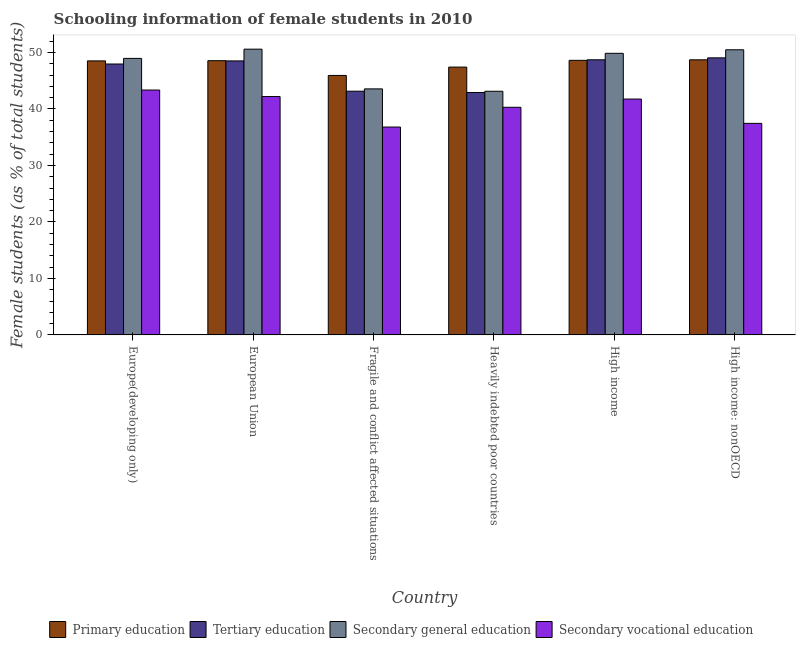How many groups of bars are there?
Your response must be concise. 6. How many bars are there on the 3rd tick from the left?
Give a very brief answer. 4. How many bars are there on the 4th tick from the right?
Make the answer very short. 4. What is the label of the 6th group of bars from the left?
Offer a terse response. High income: nonOECD. In how many cases, is the number of bars for a given country not equal to the number of legend labels?
Provide a short and direct response. 0. What is the percentage of female students in primary education in Europe(developing only)?
Provide a succinct answer. 48.5. Across all countries, what is the maximum percentage of female students in secondary vocational education?
Your response must be concise. 43.34. Across all countries, what is the minimum percentage of female students in secondary education?
Give a very brief answer. 43.13. In which country was the percentage of female students in secondary vocational education maximum?
Give a very brief answer. Europe(developing only). In which country was the percentage of female students in secondary education minimum?
Provide a succinct answer. Heavily indebted poor countries. What is the total percentage of female students in secondary vocational education in the graph?
Ensure brevity in your answer.  241.81. What is the difference between the percentage of female students in secondary education in Fragile and conflict affected situations and that in High income?
Provide a succinct answer. -6.29. What is the difference between the percentage of female students in secondary education in European Union and the percentage of female students in tertiary education in Fragile and conflict affected situations?
Provide a short and direct response. 7.44. What is the average percentage of female students in primary education per country?
Ensure brevity in your answer.  47.95. What is the difference between the percentage of female students in tertiary education and percentage of female students in secondary vocational education in Fragile and conflict affected situations?
Provide a succinct answer. 6.35. What is the ratio of the percentage of female students in secondary vocational education in Fragile and conflict affected situations to that in Heavily indebted poor countries?
Offer a terse response. 0.91. Is the difference between the percentage of female students in secondary vocational education in Fragile and conflict affected situations and Heavily indebted poor countries greater than the difference between the percentage of female students in tertiary education in Fragile and conflict affected situations and Heavily indebted poor countries?
Provide a succinct answer. No. What is the difference between the highest and the second highest percentage of female students in tertiary education?
Offer a terse response. 0.34. What is the difference between the highest and the lowest percentage of female students in tertiary education?
Give a very brief answer. 6.13. In how many countries, is the percentage of female students in tertiary education greater than the average percentage of female students in tertiary education taken over all countries?
Ensure brevity in your answer.  4. Is the sum of the percentage of female students in primary education in Europe(developing only) and Heavily indebted poor countries greater than the maximum percentage of female students in tertiary education across all countries?
Ensure brevity in your answer.  Yes. What does the 2nd bar from the left in High income represents?
Your answer should be compact. Tertiary education. What does the 3rd bar from the right in Europe(developing only) represents?
Offer a terse response. Tertiary education. What is the difference between two consecutive major ticks on the Y-axis?
Give a very brief answer. 10. Does the graph contain grids?
Offer a terse response. No. Where does the legend appear in the graph?
Offer a very short reply. Bottom center. What is the title of the graph?
Ensure brevity in your answer.  Schooling information of female students in 2010. Does "Secondary general" appear as one of the legend labels in the graph?
Your response must be concise. No. What is the label or title of the X-axis?
Your answer should be compact. Country. What is the label or title of the Y-axis?
Provide a short and direct response. Female students (as % of total students). What is the Female students (as % of total students) in Primary education in Europe(developing only)?
Offer a terse response. 48.5. What is the Female students (as % of total students) in Tertiary education in Europe(developing only)?
Provide a short and direct response. 47.95. What is the Female students (as % of total students) in Secondary general education in Europe(developing only)?
Provide a succinct answer. 48.94. What is the Female students (as % of total students) of Secondary vocational education in Europe(developing only)?
Provide a short and direct response. 43.34. What is the Female students (as % of total students) of Primary education in European Union?
Your answer should be very brief. 48.54. What is the Female students (as % of total students) in Tertiary education in European Union?
Provide a succinct answer. 48.5. What is the Female students (as % of total students) in Secondary general education in European Union?
Make the answer very short. 50.58. What is the Female students (as % of total students) of Secondary vocational education in European Union?
Ensure brevity in your answer.  42.19. What is the Female students (as % of total students) of Primary education in Fragile and conflict affected situations?
Provide a short and direct response. 45.93. What is the Female students (as % of total students) in Tertiary education in Fragile and conflict affected situations?
Keep it short and to the point. 43.14. What is the Female students (as % of total students) in Secondary general education in Fragile and conflict affected situations?
Your response must be concise. 43.55. What is the Female students (as % of total students) in Secondary vocational education in Fragile and conflict affected situations?
Your response must be concise. 36.79. What is the Female students (as % of total students) in Primary education in Heavily indebted poor countries?
Your response must be concise. 47.41. What is the Female students (as % of total students) of Tertiary education in Heavily indebted poor countries?
Your answer should be very brief. 42.91. What is the Female students (as % of total students) in Secondary general education in Heavily indebted poor countries?
Your response must be concise. 43.13. What is the Female students (as % of total students) of Secondary vocational education in Heavily indebted poor countries?
Your answer should be compact. 40.29. What is the Female students (as % of total students) in Primary education in High income?
Your answer should be compact. 48.6. What is the Female students (as % of total students) of Tertiary education in High income?
Offer a terse response. 48.7. What is the Female students (as % of total students) in Secondary general education in High income?
Offer a terse response. 49.84. What is the Female students (as % of total students) of Secondary vocational education in High income?
Provide a succinct answer. 41.75. What is the Female students (as % of total students) of Primary education in High income: nonOECD?
Give a very brief answer. 48.69. What is the Female students (as % of total students) in Tertiary education in High income: nonOECD?
Give a very brief answer. 49.04. What is the Female students (as % of total students) of Secondary general education in High income: nonOECD?
Your answer should be very brief. 50.47. What is the Female students (as % of total students) of Secondary vocational education in High income: nonOECD?
Offer a very short reply. 37.45. Across all countries, what is the maximum Female students (as % of total students) of Primary education?
Your response must be concise. 48.69. Across all countries, what is the maximum Female students (as % of total students) of Tertiary education?
Make the answer very short. 49.04. Across all countries, what is the maximum Female students (as % of total students) in Secondary general education?
Your answer should be compact. 50.58. Across all countries, what is the maximum Female students (as % of total students) in Secondary vocational education?
Your answer should be compact. 43.34. Across all countries, what is the minimum Female students (as % of total students) of Primary education?
Ensure brevity in your answer.  45.93. Across all countries, what is the minimum Female students (as % of total students) in Tertiary education?
Offer a terse response. 42.91. Across all countries, what is the minimum Female students (as % of total students) in Secondary general education?
Keep it short and to the point. 43.13. Across all countries, what is the minimum Female students (as % of total students) of Secondary vocational education?
Offer a terse response. 36.79. What is the total Female students (as % of total students) in Primary education in the graph?
Provide a succinct answer. 287.67. What is the total Female students (as % of total students) in Tertiary education in the graph?
Your answer should be compact. 280.24. What is the total Female students (as % of total students) of Secondary general education in the graph?
Your response must be concise. 286.51. What is the total Female students (as % of total students) in Secondary vocational education in the graph?
Give a very brief answer. 241.81. What is the difference between the Female students (as % of total students) of Primary education in Europe(developing only) and that in European Union?
Your answer should be compact. -0.04. What is the difference between the Female students (as % of total students) in Tertiary education in Europe(developing only) and that in European Union?
Offer a very short reply. -0.55. What is the difference between the Female students (as % of total students) of Secondary general education in Europe(developing only) and that in European Union?
Provide a short and direct response. -1.64. What is the difference between the Female students (as % of total students) of Secondary vocational education in Europe(developing only) and that in European Union?
Make the answer very short. 1.15. What is the difference between the Female students (as % of total students) in Primary education in Europe(developing only) and that in Fragile and conflict affected situations?
Provide a short and direct response. 2.57. What is the difference between the Female students (as % of total students) of Tertiary education in Europe(developing only) and that in Fragile and conflict affected situations?
Provide a succinct answer. 4.81. What is the difference between the Female students (as % of total students) of Secondary general education in Europe(developing only) and that in Fragile and conflict affected situations?
Provide a succinct answer. 5.39. What is the difference between the Female students (as % of total students) of Secondary vocational education in Europe(developing only) and that in Fragile and conflict affected situations?
Make the answer very short. 6.55. What is the difference between the Female students (as % of total students) in Primary education in Europe(developing only) and that in Heavily indebted poor countries?
Provide a succinct answer. 1.1. What is the difference between the Female students (as % of total students) in Tertiary education in Europe(developing only) and that in Heavily indebted poor countries?
Your response must be concise. 5.04. What is the difference between the Female students (as % of total students) in Secondary general education in Europe(developing only) and that in Heavily indebted poor countries?
Offer a very short reply. 5.81. What is the difference between the Female students (as % of total students) of Secondary vocational education in Europe(developing only) and that in Heavily indebted poor countries?
Offer a terse response. 3.05. What is the difference between the Female students (as % of total students) of Primary education in Europe(developing only) and that in High income?
Keep it short and to the point. -0.1. What is the difference between the Female students (as % of total students) in Tertiary education in Europe(developing only) and that in High income?
Make the answer very short. -0.75. What is the difference between the Female students (as % of total students) of Secondary general education in Europe(developing only) and that in High income?
Your answer should be compact. -0.9. What is the difference between the Female students (as % of total students) of Secondary vocational education in Europe(developing only) and that in High income?
Provide a succinct answer. 1.6. What is the difference between the Female students (as % of total students) in Primary education in Europe(developing only) and that in High income: nonOECD?
Give a very brief answer. -0.19. What is the difference between the Female students (as % of total students) of Tertiary education in Europe(developing only) and that in High income: nonOECD?
Provide a succinct answer. -1.09. What is the difference between the Female students (as % of total students) in Secondary general education in Europe(developing only) and that in High income: nonOECD?
Provide a short and direct response. -1.53. What is the difference between the Female students (as % of total students) in Secondary vocational education in Europe(developing only) and that in High income: nonOECD?
Your answer should be compact. 5.9. What is the difference between the Female students (as % of total students) in Primary education in European Union and that in Fragile and conflict affected situations?
Provide a short and direct response. 2.61. What is the difference between the Female students (as % of total students) of Tertiary education in European Union and that in Fragile and conflict affected situations?
Offer a terse response. 5.36. What is the difference between the Female students (as % of total students) in Secondary general education in European Union and that in Fragile and conflict affected situations?
Offer a very short reply. 7.03. What is the difference between the Female students (as % of total students) of Secondary vocational education in European Union and that in Fragile and conflict affected situations?
Provide a short and direct response. 5.4. What is the difference between the Female students (as % of total students) of Primary education in European Union and that in Heavily indebted poor countries?
Ensure brevity in your answer.  1.13. What is the difference between the Female students (as % of total students) in Tertiary education in European Union and that in Heavily indebted poor countries?
Your response must be concise. 5.59. What is the difference between the Female students (as % of total students) of Secondary general education in European Union and that in Heavily indebted poor countries?
Keep it short and to the point. 7.45. What is the difference between the Female students (as % of total students) of Secondary vocational education in European Union and that in Heavily indebted poor countries?
Your response must be concise. 1.9. What is the difference between the Female students (as % of total students) of Primary education in European Union and that in High income?
Make the answer very short. -0.06. What is the difference between the Female students (as % of total students) in Tertiary education in European Union and that in High income?
Keep it short and to the point. -0.2. What is the difference between the Female students (as % of total students) in Secondary general education in European Union and that in High income?
Your answer should be compact. 0.74. What is the difference between the Female students (as % of total students) in Secondary vocational education in European Union and that in High income?
Your answer should be very brief. 0.44. What is the difference between the Female students (as % of total students) in Primary education in European Union and that in High income: nonOECD?
Keep it short and to the point. -0.15. What is the difference between the Female students (as % of total students) in Tertiary education in European Union and that in High income: nonOECD?
Make the answer very short. -0.54. What is the difference between the Female students (as % of total students) of Secondary general education in European Union and that in High income: nonOECD?
Make the answer very short. 0.11. What is the difference between the Female students (as % of total students) in Secondary vocational education in European Union and that in High income: nonOECD?
Make the answer very short. 4.74. What is the difference between the Female students (as % of total students) of Primary education in Fragile and conflict affected situations and that in Heavily indebted poor countries?
Give a very brief answer. -1.48. What is the difference between the Female students (as % of total students) of Tertiary education in Fragile and conflict affected situations and that in Heavily indebted poor countries?
Offer a terse response. 0.23. What is the difference between the Female students (as % of total students) in Secondary general education in Fragile and conflict affected situations and that in Heavily indebted poor countries?
Keep it short and to the point. 0.42. What is the difference between the Female students (as % of total students) of Secondary vocational education in Fragile and conflict affected situations and that in Heavily indebted poor countries?
Provide a succinct answer. -3.5. What is the difference between the Female students (as % of total students) of Primary education in Fragile and conflict affected situations and that in High income?
Ensure brevity in your answer.  -2.67. What is the difference between the Female students (as % of total students) of Tertiary education in Fragile and conflict affected situations and that in High income?
Ensure brevity in your answer.  -5.56. What is the difference between the Female students (as % of total students) of Secondary general education in Fragile and conflict affected situations and that in High income?
Make the answer very short. -6.29. What is the difference between the Female students (as % of total students) in Secondary vocational education in Fragile and conflict affected situations and that in High income?
Your answer should be compact. -4.96. What is the difference between the Female students (as % of total students) in Primary education in Fragile and conflict affected situations and that in High income: nonOECD?
Make the answer very short. -2.76. What is the difference between the Female students (as % of total students) in Tertiary education in Fragile and conflict affected situations and that in High income: nonOECD?
Offer a terse response. -5.9. What is the difference between the Female students (as % of total students) of Secondary general education in Fragile and conflict affected situations and that in High income: nonOECD?
Make the answer very short. -6.92. What is the difference between the Female students (as % of total students) of Secondary vocational education in Fragile and conflict affected situations and that in High income: nonOECD?
Make the answer very short. -0.65. What is the difference between the Female students (as % of total students) in Primary education in Heavily indebted poor countries and that in High income?
Your response must be concise. -1.19. What is the difference between the Female students (as % of total students) in Tertiary education in Heavily indebted poor countries and that in High income?
Provide a succinct answer. -5.79. What is the difference between the Female students (as % of total students) in Secondary general education in Heavily indebted poor countries and that in High income?
Ensure brevity in your answer.  -6.71. What is the difference between the Female students (as % of total students) of Secondary vocational education in Heavily indebted poor countries and that in High income?
Make the answer very short. -1.46. What is the difference between the Female students (as % of total students) of Primary education in Heavily indebted poor countries and that in High income: nonOECD?
Make the answer very short. -1.29. What is the difference between the Female students (as % of total students) in Tertiary education in Heavily indebted poor countries and that in High income: nonOECD?
Keep it short and to the point. -6.13. What is the difference between the Female students (as % of total students) of Secondary general education in Heavily indebted poor countries and that in High income: nonOECD?
Give a very brief answer. -7.34. What is the difference between the Female students (as % of total students) in Secondary vocational education in Heavily indebted poor countries and that in High income: nonOECD?
Make the answer very short. 2.84. What is the difference between the Female students (as % of total students) in Primary education in High income and that in High income: nonOECD?
Make the answer very short. -0.09. What is the difference between the Female students (as % of total students) of Tertiary education in High income and that in High income: nonOECD?
Ensure brevity in your answer.  -0.34. What is the difference between the Female students (as % of total students) of Secondary general education in High income and that in High income: nonOECD?
Keep it short and to the point. -0.63. What is the difference between the Female students (as % of total students) of Secondary vocational education in High income and that in High income: nonOECD?
Provide a succinct answer. 4.3. What is the difference between the Female students (as % of total students) in Primary education in Europe(developing only) and the Female students (as % of total students) in Tertiary education in European Union?
Your answer should be compact. 0. What is the difference between the Female students (as % of total students) in Primary education in Europe(developing only) and the Female students (as % of total students) in Secondary general education in European Union?
Provide a succinct answer. -2.08. What is the difference between the Female students (as % of total students) of Primary education in Europe(developing only) and the Female students (as % of total students) of Secondary vocational education in European Union?
Ensure brevity in your answer.  6.31. What is the difference between the Female students (as % of total students) in Tertiary education in Europe(developing only) and the Female students (as % of total students) in Secondary general education in European Union?
Offer a very short reply. -2.63. What is the difference between the Female students (as % of total students) of Tertiary education in Europe(developing only) and the Female students (as % of total students) of Secondary vocational education in European Union?
Offer a very short reply. 5.76. What is the difference between the Female students (as % of total students) in Secondary general education in Europe(developing only) and the Female students (as % of total students) in Secondary vocational education in European Union?
Give a very brief answer. 6.75. What is the difference between the Female students (as % of total students) of Primary education in Europe(developing only) and the Female students (as % of total students) of Tertiary education in Fragile and conflict affected situations?
Ensure brevity in your answer.  5.36. What is the difference between the Female students (as % of total students) in Primary education in Europe(developing only) and the Female students (as % of total students) in Secondary general education in Fragile and conflict affected situations?
Give a very brief answer. 4.95. What is the difference between the Female students (as % of total students) in Primary education in Europe(developing only) and the Female students (as % of total students) in Secondary vocational education in Fragile and conflict affected situations?
Keep it short and to the point. 11.71. What is the difference between the Female students (as % of total students) of Tertiary education in Europe(developing only) and the Female students (as % of total students) of Secondary general education in Fragile and conflict affected situations?
Provide a succinct answer. 4.4. What is the difference between the Female students (as % of total students) in Tertiary education in Europe(developing only) and the Female students (as % of total students) in Secondary vocational education in Fragile and conflict affected situations?
Ensure brevity in your answer.  11.16. What is the difference between the Female students (as % of total students) in Secondary general education in Europe(developing only) and the Female students (as % of total students) in Secondary vocational education in Fragile and conflict affected situations?
Your answer should be compact. 12.15. What is the difference between the Female students (as % of total students) of Primary education in Europe(developing only) and the Female students (as % of total students) of Tertiary education in Heavily indebted poor countries?
Your answer should be compact. 5.59. What is the difference between the Female students (as % of total students) of Primary education in Europe(developing only) and the Female students (as % of total students) of Secondary general education in Heavily indebted poor countries?
Ensure brevity in your answer.  5.38. What is the difference between the Female students (as % of total students) in Primary education in Europe(developing only) and the Female students (as % of total students) in Secondary vocational education in Heavily indebted poor countries?
Provide a short and direct response. 8.21. What is the difference between the Female students (as % of total students) of Tertiary education in Europe(developing only) and the Female students (as % of total students) of Secondary general education in Heavily indebted poor countries?
Make the answer very short. 4.82. What is the difference between the Female students (as % of total students) in Tertiary education in Europe(developing only) and the Female students (as % of total students) in Secondary vocational education in Heavily indebted poor countries?
Offer a terse response. 7.66. What is the difference between the Female students (as % of total students) of Secondary general education in Europe(developing only) and the Female students (as % of total students) of Secondary vocational education in Heavily indebted poor countries?
Keep it short and to the point. 8.65. What is the difference between the Female students (as % of total students) of Primary education in Europe(developing only) and the Female students (as % of total students) of Tertiary education in High income?
Your answer should be very brief. -0.19. What is the difference between the Female students (as % of total students) of Primary education in Europe(developing only) and the Female students (as % of total students) of Secondary general education in High income?
Your answer should be very brief. -1.34. What is the difference between the Female students (as % of total students) in Primary education in Europe(developing only) and the Female students (as % of total students) in Secondary vocational education in High income?
Offer a terse response. 6.76. What is the difference between the Female students (as % of total students) in Tertiary education in Europe(developing only) and the Female students (as % of total students) in Secondary general education in High income?
Offer a very short reply. -1.89. What is the difference between the Female students (as % of total students) in Tertiary education in Europe(developing only) and the Female students (as % of total students) in Secondary vocational education in High income?
Offer a very short reply. 6.2. What is the difference between the Female students (as % of total students) in Secondary general education in Europe(developing only) and the Female students (as % of total students) in Secondary vocational education in High income?
Ensure brevity in your answer.  7.2. What is the difference between the Female students (as % of total students) of Primary education in Europe(developing only) and the Female students (as % of total students) of Tertiary education in High income: nonOECD?
Give a very brief answer. -0.54. What is the difference between the Female students (as % of total students) in Primary education in Europe(developing only) and the Female students (as % of total students) in Secondary general education in High income: nonOECD?
Your response must be concise. -1.97. What is the difference between the Female students (as % of total students) in Primary education in Europe(developing only) and the Female students (as % of total students) in Secondary vocational education in High income: nonOECD?
Your answer should be compact. 11.06. What is the difference between the Female students (as % of total students) in Tertiary education in Europe(developing only) and the Female students (as % of total students) in Secondary general education in High income: nonOECD?
Offer a terse response. -2.52. What is the difference between the Female students (as % of total students) in Tertiary education in Europe(developing only) and the Female students (as % of total students) in Secondary vocational education in High income: nonOECD?
Keep it short and to the point. 10.51. What is the difference between the Female students (as % of total students) of Secondary general education in Europe(developing only) and the Female students (as % of total students) of Secondary vocational education in High income: nonOECD?
Your response must be concise. 11.5. What is the difference between the Female students (as % of total students) of Primary education in European Union and the Female students (as % of total students) of Tertiary education in Fragile and conflict affected situations?
Keep it short and to the point. 5.4. What is the difference between the Female students (as % of total students) of Primary education in European Union and the Female students (as % of total students) of Secondary general education in Fragile and conflict affected situations?
Provide a short and direct response. 4.99. What is the difference between the Female students (as % of total students) in Primary education in European Union and the Female students (as % of total students) in Secondary vocational education in Fragile and conflict affected situations?
Offer a terse response. 11.75. What is the difference between the Female students (as % of total students) in Tertiary education in European Union and the Female students (as % of total students) in Secondary general education in Fragile and conflict affected situations?
Keep it short and to the point. 4.95. What is the difference between the Female students (as % of total students) of Tertiary education in European Union and the Female students (as % of total students) of Secondary vocational education in Fragile and conflict affected situations?
Offer a terse response. 11.71. What is the difference between the Female students (as % of total students) of Secondary general education in European Union and the Female students (as % of total students) of Secondary vocational education in Fragile and conflict affected situations?
Make the answer very short. 13.79. What is the difference between the Female students (as % of total students) of Primary education in European Union and the Female students (as % of total students) of Tertiary education in Heavily indebted poor countries?
Offer a terse response. 5.63. What is the difference between the Female students (as % of total students) of Primary education in European Union and the Female students (as % of total students) of Secondary general education in Heavily indebted poor countries?
Your response must be concise. 5.41. What is the difference between the Female students (as % of total students) of Primary education in European Union and the Female students (as % of total students) of Secondary vocational education in Heavily indebted poor countries?
Ensure brevity in your answer.  8.25. What is the difference between the Female students (as % of total students) of Tertiary education in European Union and the Female students (as % of total students) of Secondary general education in Heavily indebted poor countries?
Make the answer very short. 5.37. What is the difference between the Female students (as % of total students) of Tertiary education in European Union and the Female students (as % of total students) of Secondary vocational education in Heavily indebted poor countries?
Make the answer very short. 8.21. What is the difference between the Female students (as % of total students) in Secondary general education in European Union and the Female students (as % of total students) in Secondary vocational education in Heavily indebted poor countries?
Your response must be concise. 10.29. What is the difference between the Female students (as % of total students) in Primary education in European Union and the Female students (as % of total students) in Tertiary education in High income?
Keep it short and to the point. -0.16. What is the difference between the Female students (as % of total students) of Primary education in European Union and the Female students (as % of total students) of Secondary general education in High income?
Your answer should be very brief. -1.3. What is the difference between the Female students (as % of total students) of Primary education in European Union and the Female students (as % of total students) of Secondary vocational education in High income?
Give a very brief answer. 6.79. What is the difference between the Female students (as % of total students) of Tertiary education in European Union and the Female students (as % of total students) of Secondary general education in High income?
Your response must be concise. -1.34. What is the difference between the Female students (as % of total students) of Tertiary education in European Union and the Female students (as % of total students) of Secondary vocational education in High income?
Your response must be concise. 6.75. What is the difference between the Female students (as % of total students) in Secondary general education in European Union and the Female students (as % of total students) in Secondary vocational education in High income?
Make the answer very short. 8.83. What is the difference between the Female students (as % of total students) of Primary education in European Union and the Female students (as % of total students) of Tertiary education in High income: nonOECD?
Give a very brief answer. -0.5. What is the difference between the Female students (as % of total students) of Primary education in European Union and the Female students (as % of total students) of Secondary general education in High income: nonOECD?
Ensure brevity in your answer.  -1.93. What is the difference between the Female students (as % of total students) in Primary education in European Union and the Female students (as % of total students) in Secondary vocational education in High income: nonOECD?
Your response must be concise. 11.09. What is the difference between the Female students (as % of total students) of Tertiary education in European Union and the Female students (as % of total students) of Secondary general education in High income: nonOECD?
Offer a terse response. -1.97. What is the difference between the Female students (as % of total students) in Tertiary education in European Union and the Female students (as % of total students) in Secondary vocational education in High income: nonOECD?
Ensure brevity in your answer.  11.05. What is the difference between the Female students (as % of total students) of Secondary general education in European Union and the Female students (as % of total students) of Secondary vocational education in High income: nonOECD?
Provide a succinct answer. 13.13. What is the difference between the Female students (as % of total students) in Primary education in Fragile and conflict affected situations and the Female students (as % of total students) in Tertiary education in Heavily indebted poor countries?
Your response must be concise. 3.02. What is the difference between the Female students (as % of total students) in Primary education in Fragile and conflict affected situations and the Female students (as % of total students) in Secondary general education in Heavily indebted poor countries?
Make the answer very short. 2.8. What is the difference between the Female students (as % of total students) in Primary education in Fragile and conflict affected situations and the Female students (as % of total students) in Secondary vocational education in Heavily indebted poor countries?
Give a very brief answer. 5.64. What is the difference between the Female students (as % of total students) in Tertiary education in Fragile and conflict affected situations and the Female students (as % of total students) in Secondary general education in Heavily indebted poor countries?
Keep it short and to the point. 0.01. What is the difference between the Female students (as % of total students) in Tertiary education in Fragile and conflict affected situations and the Female students (as % of total students) in Secondary vocational education in Heavily indebted poor countries?
Your answer should be compact. 2.85. What is the difference between the Female students (as % of total students) in Secondary general education in Fragile and conflict affected situations and the Female students (as % of total students) in Secondary vocational education in Heavily indebted poor countries?
Ensure brevity in your answer.  3.26. What is the difference between the Female students (as % of total students) of Primary education in Fragile and conflict affected situations and the Female students (as % of total students) of Tertiary education in High income?
Offer a very short reply. -2.77. What is the difference between the Female students (as % of total students) in Primary education in Fragile and conflict affected situations and the Female students (as % of total students) in Secondary general education in High income?
Ensure brevity in your answer.  -3.91. What is the difference between the Female students (as % of total students) of Primary education in Fragile and conflict affected situations and the Female students (as % of total students) of Secondary vocational education in High income?
Your response must be concise. 4.18. What is the difference between the Female students (as % of total students) of Tertiary education in Fragile and conflict affected situations and the Female students (as % of total students) of Secondary general education in High income?
Ensure brevity in your answer.  -6.7. What is the difference between the Female students (as % of total students) of Tertiary education in Fragile and conflict affected situations and the Female students (as % of total students) of Secondary vocational education in High income?
Your answer should be compact. 1.39. What is the difference between the Female students (as % of total students) of Secondary general education in Fragile and conflict affected situations and the Female students (as % of total students) of Secondary vocational education in High income?
Ensure brevity in your answer.  1.8. What is the difference between the Female students (as % of total students) in Primary education in Fragile and conflict affected situations and the Female students (as % of total students) in Tertiary education in High income: nonOECD?
Ensure brevity in your answer.  -3.11. What is the difference between the Female students (as % of total students) in Primary education in Fragile and conflict affected situations and the Female students (as % of total students) in Secondary general education in High income: nonOECD?
Offer a terse response. -4.54. What is the difference between the Female students (as % of total students) of Primary education in Fragile and conflict affected situations and the Female students (as % of total students) of Secondary vocational education in High income: nonOECD?
Ensure brevity in your answer.  8.48. What is the difference between the Female students (as % of total students) of Tertiary education in Fragile and conflict affected situations and the Female students (as % of total students) of Secondary general education in High income: nonOECD?
Make the answer very short. -7.33. What is the difference between the Female students (as % of total students) in Tertiary education in Fragile and conflict affected situations and the Female students (as % of total students) in Secondary vocational education in High income: nonOECD?
Your answer should be compact. 5.69. What is the difference between the Female students (as % of total students) of Secondary general education in Fragile and conflict affected situations and the Female students (as % of total students) of Secondary vocational education in High income: nonOECD?
Provide a succinct answer. 6.1. What is the difference between the Female students (as % of total students) of Primary education in Heavily indebted poor countries and the Female students (as % of total students) of Tertiary education in High income?
Provide a succinct answer. -1.29. What is the difference between the Female students (as % of total students) of Primary education in Heavily indebted poor countries and the Female students (as % of total students) of Secondary general education in High income?
Ensure brevity in your answer.  -2.44. What is the difference between the Female students (as % of total students) of Primary education in Heavily indebted poor countries and the Female students (as % of total students) of Secondary vocational education in High income?
Your response must be concise. 5.66. What is the difference between the Female students (as % of total students) of Tertiary education in Heavily indebted poor countries and the Female students (as % of total students) of Secondary general education in High income?
Provide a short and direct response. -6.93. What is the difference between the Female students (as % of total students) of Tertiary education in Heavily indebted poor countries and the Female students (as % of total students) of Secondary vocational education in High income?
Give a very brief answer. 1.16. What is the difference between the Female students (as % of total students) of Secondary general education in Heavily indebted poor countries and the Female students (as % of total students) of Secondary vocational education in High income?
Ensure brevity in your answer.  1.38. What is the difference between the Female students (as % of total students) of Primary education in Heavily indebted poor countries and the Female students (as % of total students) of Tertiary education in High income: nonOECD?
Your response must be concise. -1.63. What is the difference between the Female students (as % of total students) of Primary education in Heavily indebted poor countries and the Female students (as % of total students) of Secondary general education in High income: nonOECD?
Your response must be concise. -3.06. What is the difference between the Female students (as % of total students) in Primary education in Heavily indebted poor countries and the Female students (as % of total students) in Secondary vocational education in High income: nonOECD?
Offer a very short reply. 9.96. What is the difference between the Female students (as % of total students) in Tertiary education in Heavily indebted poor countries and the Female students (as % of total students) in Secondary general education in High income: nonOECD?
Your answer should be compact. -7.56. What is the difference between the Female students (as % of total students) of Tertiary education in Heavily indebted poor countries and the Female students (as % of total students) of Secondary vocational education in High income: nonOECD?
Offer a very short reply. 5.46. What is the difference between the Female students (as % of total students) of Secondary general education in Heavily indebted poor countries and the Female students (as % of total students) of Secondary vocational education in High income: nonOECD?
Give a very brief answer. 5.68. What is the difference between the Female students (as % of total students) in Primary education in High income and the Female students (as % of total students) in Tertiary education in High income: nonOECD?
Your response must be concise. -0.44. What is the difference between the Female students (as % of total students) in Primary education in High income and the Female students (as % of total students) in Secondary general education in High income: nonOECD?
Your answer should be very brief. -1.87. What is the difference between the Female students (as % of total students) in Primary education in High income and the Female students (as % of total students) in Secondary vocational education in High income: nonOECD?
Keep it short and to the point. 11.16. What is the difference between the Female students (as % of total students) in Tertiary education in High income and the Female students (as % of total students) in Secondary general education in High income: nonOECD?
Your answer should be compact. -1.77. What is the difference between the Female students (as % of total students) in Tertiary education in High income and the Female students (as % of total students) in Secondary vocational education in High income: nonOECD?
Offer a terse response. 11.25. What is the difference between the Female students (as % of total students) in Secondary general education in High income and the Female students (as % of total students) in Secondary vocational education in High income: nonOECD?
Keep it short and to the point. 12.4. What is the average Female students (as % of total students) of Primary education per country?
Make the answer very short. 47.95. What is the average Female students (as % of total students) in Tertiary education per country?
Provide a succinct answer. 46.71. What is the average Female students (as % of total students) of Secondary general education per country?
Give a very brief answer. 47.75. What is the average Female students (as % of total students) in Secondary vocational education per country?
Your answer should be very brief. 40.3. What is the difference between the Female students (as % of total students) of Primary education and Female students (as % of total students) of Tertiary education in Europe(developing only)?
Your answer should be compact. 0.55. What is the difference between the Female students (as % of total students) of Primary education and Female students (as % of total students) of Secondary general education in Europe(developing only)?
Your answer should be very brief. -0.44. What is the difference between the Female students (as % of total students) of Primary education and Female students (as % of total students) of Secondary vocational education in Europe(developing only)?
Provide a short and direct response. 5.16. What is the difference between the Female students (as % of total students) of Tertiary education and Female students (as % of total students) of Secondary general education in Europe(developing only)?
Your response must be concise. -0.99. What is the difference between the Female students (as % of total students) in Tertiary education and Female students (as % of total students) in Secondary vocational education in Europe(developing only)?
Your answer should be very brief. 4.61. What is the difference between the Female students (as % of total students) in Secondary general education and Female students (as % of total students) in Secondary vocational education in Europe(developing only)?
Keep it short and to the point. 5.6. What is the difference between the Female students (as % of total students) in Primary education and Female students (as % of total students) in Tertiary education in European Union?
Ensure brevity in your answer.  0.04. What is the difference between the Female students (as % of total students) of Primary education and Female students (as % of total students) of Secondary general education in European Union?
Keep it short and to the point. -2.04. What is the difference between the Female students (as % of total students) of Primary education and Female students (as % of total students) of Secondary vocational education in European Union?
Your answer should be compact. 6.35. What is the difference between the Female students (as % of total students) in Tertiary education and Female students (as % of total students) in Secondary general education in European Union?
Your answer should be very brief. -2.08. What is the difference between the Female students (as % of total students) in Tertiary education and Female students (as % of total students) in Secondary vocational education in European Union?
Make the answer very short. 6.31. What is the difference between the Female students (as % of total students) in Secondary general education and Female students (as % of total students) in Secondary vocational education in European Union?
Provide a succinct answer. 8.39. What is the difference between the Female students (as % of total students) of Primary education and Female students (as % of total students) of Tertiary education in Fragile and conflict affected situations?
Make the answer very short. 2.79. What is the difference between the Female students (as % of total students) of Primary education and Female students (as % of total students) of Secondary general education in Fragile and conflict affected situations?
Make the answer very short. 2.38. What is the difference between the Female students (as % of total students) of Primary education and Female students (as % of total students) of Secondary vocational education in Fragile and conflict affected situations?
Give a very brief answer. 9.14. What is the difference between the Female students (as % of total students) in Tertiary education and Female students (as % of total students) in Secondary general education in Fragile and conflict affected situations?
Provide a succinct answer. -0.41. What is the difference between the Female students (as % of total students) in Tertiary education and Female students (as % of total students) in Secondary vocational education in Fragile and conflict affected situations?
Your answer should be compact. 6.35. What is the difference between the Female students (as % of total students) of Secondary general education and Female students (as % of total students) of Secondary vocational education in Fragile and conflict affected situations?
Keep it short and to the point. 6.76. What is the difference between the Female students (as % of total students) of Primary education and Female students (as % of total students) of Tertiary education in Heavily indebted poor countries?
Your answer should be compact. 4.5. What is the difference between the Female students (as % of total students) of Primary education and Female students (as % of total students) of Secondary general education in Heavily indebted poor countries?
Your response must be concise. 4.28. What is the difference between the Female students (as % of total students) in Primary education and Female students (as % of total students) in Secondary vocational education in Heavily indebted poor countries?
Ensure brevity in your answer.  7.12. What is the difference between the Female students (as % of total students) in Tertiary education and Female students (as % of total students) in Secondary general education in Heavily indebted poor countries?
Offer a terse response. -0.22. What is the difference between the Female students (as % of total students) of Tertiary education and Female students (as % of total students) of Secondary vocational education in Heavily indebted poor countries?
Provide a short and direct response. 2.62. What is the difference between the Female students (as % of total students) in Secondary general education and Female students (as % of total students) in Secondary vocational education in Heavily indebted poor countries?
Make the answer very short. 2.84. What is the difference between the Female students (as % of total students) of Primary education and Female students (as % of total students) of Tertiary education in High income?
Your answer should be very brief. -0.1. What is the difference between the Female students (as % of total students) in Primary education and Female students (as % of total students) in Secondary general education in High income?
Provide a short and direct response. -1.24. What is the difference between the Female students (as % of total students) of Primary education and Female students (as % of total students) of Secondary vocational education in High income?
Offer a terse response. 6.85. What is the difference between the Female students (as % of total students) of Tertiary education and Female students (as % of total students) of Secondary general education in High income?
Keep it short and to the point. -1.14. What is the difference between the Female students (as % of total students) of Tertiary education and Female students (as % of total students) of Secondary vocational education in High income?
Provide a short and direct response. 6.95. What is the difference between the Female students (as % of total students) of Secondary general education and Female students (as % of total students) of Secondary vocational education in High income?
Keep it short and to the point. 8.09. What is the difference between the Female students (as % of total students) of Primary education and Female students (as % of total students) of Tertiary education in High income: nonOECD?
Make the answer very short. -0.35. What is the difference between the Female students (as % of total students) of Primary education and Female students (as % of total students) of Secondary general education in High income: nonOECD?
Your answer should be very brief. -1.78. What is the difference between the Female students (as % of total students) in Primary education and Female students (as % of total students) in Secondary vocational education in High income: nonOECD?
Make the answer very short. 11.25. What is the difference between the Female students (as % of total students) in Tertiary education and Female students (as % of total students) in Secondary general education in High income: nonOECD?
Your response must be concise. -1.43. What is the difference between the Female students (as % of total students) in Tertiary education and Female students (as % of total students) in Secondary vocational education in High income: nonOECD?
Give a very brief answer. 11.6. What is the difference between the Female students (as % of total students) in Secondary general education and Female students (as % of total students) in Secondary vocational education in High income: nonOECD?
Offer a very short reply. 13.02. What is the ratio of the Female students (as % of total students) of Primary education in Europe(developing only) to that in European Union?
Offer a terse response. 1. What is the ratio of the Female students (as % of total students) in Tertiary education in Europe(developing only) to that in European Union?
Provide a succinct answer. 0.99. What is the ratio of the Female students (as % of total students) in Secondary general education in Europe(developing only) to that in European Union?
Your answer should be very brief. 0.97. What is the ratio of the Female students (as % of total students) in Secondary vocational education in Europe(developing only) to that in European Union?
Give a very brief answer. 1.03. What is the ratio of the Female students (as % of total students) of Primary education in Europe(developing only) to that in Fragile and conflict affected situations?
Offer a very short reply. 1.06. What is the ratio of the Female students (as % of total students) in Tertiary education in Europe(developing only) to that in Fragile and conflict affected situations?
Provide a short and direct response. 1.11. What is the ratio of the Female students (as % of total students) of Secondary general education in Europe(developing only) to that in Fragile and conflict affected situations?
Your response must be concise. 1.12. What is the ratio of the Female students (as % of total students) of Secondary vocational education in Europe(developing only) to that in Fragile and conflict affected situations?
Offer a terse response. 1.18. What is the ratio of the Female students (as % of total students) of Primary education in Europe(developing only) to that in Heavily indebted poor countries?
Keep it short and to the point. 1.02. What is the ratio of the Female students (as % of total students) of Tertiary education in Europe(developing only) to that in Heavily indebted poor countries?
Ensure brevity in your answer.  1.12. What is the ratio of the Female students (as % of total students) of Secondary general education in Europe(developing only) to that in Heavily indebted poor countries?
Make the answer very short. 1.13. What is the ratio of the Female students (as % of total students) in Secondary vocational education in Europe(developing only) to that in Heavily indebted poor countries?
Keep it short and to the point. 1.08. What is the ratio of the Female students (as % of total students) of Primary education in Europe(developing only) to that in High income?
Ensure brevity in your answer.  1. What is the ratio of the Female students (as % of total students) of Tertiary education in Europe(developing only) to that in High income?
Provide a succinct answer. 0.98. What is the ratio of the Female students (as % of total students) of Secondary vocational education in Europe(developing only) to that in High income?
Your answer should be very brief. 1.04. What is the ratio of the Female students (as % of total students) of Tertiary education in Europe(developing only) to that in High income: nonOECD?
Your answer should be compact. 0.98. What is the ratio of the Female students (as % of total students) in Secondary general education in Europe(developing only) to that in High income: nonOECD?
Your answer should be compact. 0.97. What is the ratio of the Female students (as % of total students) of Secondary vocational education in Europe(developing only) to that in High income: nonOECD?
Provide a succinct answer. 1.16. What is the ratio of the Female students (as % of total students) in Primary education in European Union to that in Fragile and conflict affected situations?
Your answer should be very brief. 1.06. What is the ratio of the Female students (as % of total students) of Tertiary education in European Union to that in Fragile and conflict affected situations?
Provide a succinct answer. 1.12. What is the ratio of the Female students (as % of total students) of Secondary general education in European Union to that in Fragile and conflict affected situations?
Keep it short and to the point. 1.16. What is the ratio of the Female students (as % of total students) of Secondary vocational education in European Union to that in Fragile and conflict affected situations?
Offer a terse response. 1.15. What is the ratio of the Female students (as % of total students) in Primary education in European Union to that in Heavily indebted poor countries?
Give a very brief answer. 1.02. What is the ratio of the Female students (as % of total students) in Tertiary education in European Union to that in Heavily indebted poor countries?
Provide a short and direct response. 1.13. What is the ratio of the Female students (as % of total students) in Secondary general education in European Union to that in Heavily indebted poor countries?
Your answer should be very brief. 1.17. What is the ratio of the Female students (as % of total students) of Secondary vocational education in European Union to that in Heavily indebted poor countries?
Offer a terse response. 1.05. What is the ratio of the Female students (as % of total students) in Secondary general education in European Union to that in High income?
Provide a short and direct response. 1.01. What is the ratio of the Female students (as % of total students) in Secondary vocational education in European Union to that in High income?
Make the answer very short. 1.01. What is the ratio of the Female students (as % of total students) in Primary education in European Union to that in High income: nonOECD?
Offer a terse response. 1. What is the ratio of the Female students (as % of total students) of Secondary vocational education in European Union to that in High income: nonOECD?
Your answer should be very brief. 1.13. What is the ratio of the Female students (as % of total students) of Primary education in Fragile and conflict affected situations to that in Heavily indebted poor countries?
Offer a very short reply. 0.97. What is the ratio of the Female students (as % of total students) in Tertiary education in Fragile and conflict affected situations to that in Heavily indebted poor countries?
Your response must be concise. 1.01. What is the ratio of the Female students (as % of total students) in Secondary general education in Fragile and conflict affected situations to that in Heavily indebted poor countries?
Offer a very short reply. 1.01. What is the ratio of the Female students (as % of total students) in Secondary vocational education in Fragile and conflict affected situations to that in Heavily indebted poor countries?
Ensure brevity in your answer.  0.91. What is the ratio of the Female students (as % of total students) of Primary education in Fragile and conflict affected situations to that in High income?
Keep it short and to the point. 0.94. What is the ratio of the Female students (as % of total students) of Tertiary education in Fragile and conflict affected situations to that in High income?
Offer a terse response. 0.89. What is the ratio of the Female students (as % of total students) in Secondary general education in Fragile and conflict affected situations to that in High income?
Provide a succinct answer. 0.87. What is the ratio of the Female students (as % of total students) in Secondary vocational education in Fragile and conflict affected situations to that in High income?
Offer a terse response. 0.88. What is the ratio of the Female students (as % of total students) of Primary education in Fragile and conflict affected situations to that in High income: nonOECD?
Your response must be concise. 0.94. What is the ratio of the Female students (as % of total students) in Tertiary education in Fragile and conflict affected situations to that in High income: nonOECD?
Provide a short and direct response. 0.88. What is the ratio of the Female students (as % of total students) in Secondary general education in Fragile and conflict affected situations to that in High income: nonOECD?
Give a very brief answer. 0.86. What is the ratio of the Female students (as % of total students) of Secondary vocational education in Fragile and conflict affected situations to that in High income: nonOECD?
Your answer should be very brief. 0.98. What is the ratio of the Female students (as % of total students) of Primary education in Heavily indebted poor countries to that in High income?
Offer a very short reply. 0.98. What is the ratio of the Female students (as % of total students) in Tertiary education in Heavily indebted poor countries to that in High income?
Offer a terse response. 0.88. What is the ratio of the Female students (as % of total students) in Secondary general education in Heavily indebted poor countries to that in High income?
Make the answer very short. 0.87. What is the ratio of the Female students (as % of total students) in Secondary vocational education in Heavily indebted poor countries to that in High income?
Offer a terse response. 0.97. What is the ratio of the Female students (as % of total students) in Primary education in Heavily indebted poor countries to that in High income: nonOECD?
Give a very brief answer. 0.97. What is the ratio of the Female students (as % of total students) in Tertiary education in Heavily indebted poor countries to that in High income: nonOECD?
Give a very brief answer. 0.88. What is the ratio of the Female students (as % of total students) in Secondary general education in Heavily indebted poor countries to that in High income: nonOECD?
Offer a terse response. 0.85. What is the ratio of the Female students (as % of total students) in Secondary vocational education in Heavily indebted poor countries to that in High income: nonOECD?
Provide a short and direct response. 1.08. What is the ratio of the Female students (as % of total students) of Primary education in High income to that in High income: nonOECD?
Make the answer very short. 1. What is the ratio of the Female students (as % of total students) in Secondary general education in High income to that in High income: nonOECD?
Your response must be concise. 0.99. What is the ratio of the Female students (as % of total students) of Secondary vocational education in High income to that in High income: nonOECD?
Offer a terse response. 1.11. What is the difference between the highest and the second highest Female students (as % of total students) of Primary education?
Keep it short and to the point. 0.09. What is the difference between the highest and the second highest Female students (as % of total students) of Tertiary education?
Make the answer very short. 0.34. What is the difference between the highest and the second highest Female students (as % of total students) in Secondary general education?
Offer a very short reply. 0.11. What is the difference between the highest and the second highest Female students (as % of total students) of Secondary vocational education?
Make the answer very short. 1.15. What is the difference between the highest and the lowest Female students (as % of total students) of Primary education?
Your answer should be compact. 2.76. What is the difference between the highest and the lowest Female students (as % of total students) in Tertiary education?
Your answer should be very brief. 6.13. What is the difference between the highest and the lowest Female students (as % of total students) of Secondary general education?
Your answer should be very brief. 7.45. What is the difference between the highest and the lowest Female students (as % of total students) of Secondary vocational education?
Your answer should be very brief. 6.55. 